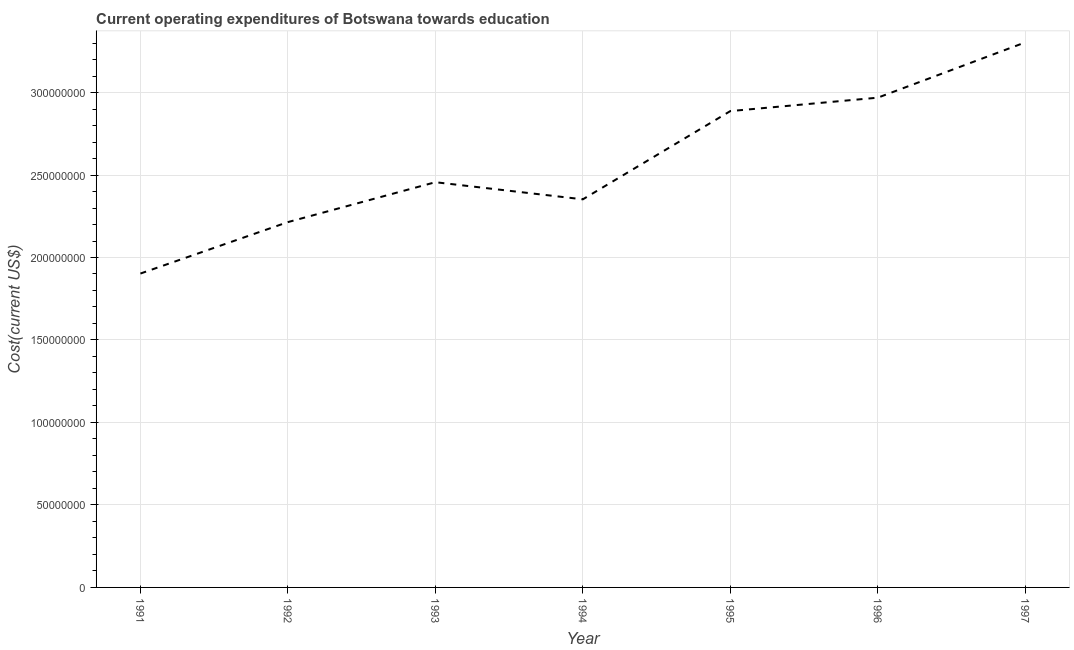What is the education expenditure in 1993?
Make the answer very short. 2.46e+08. Across all years, what is the maximum education expenditure?
Your response must be concise. 3.30e+08. Across all years, what is the minimum education expenditure?
Your response must be concise. 1.90e+08. In which year was the education expenditure minimum?
Provide a short and direct response. 1991. What is the sum of the education expenditure?
Offer a terse response. 1.81e+09. What is the difference between the education expenditure in 1996 and 1997?
Give a very brief answer. -3.35e+07. What is the average education expenditure per year?
Keep it short and to the point. 2.58e+08. What is the median education expenditure?
Provide a succinct answer. 2.46e+08. Do a majority of the years between 1996 and 1994 (inclusive) have education expenditure greater than 260000000 US$?
Your answer should be very brief. No. What is the ratio of the education expenditure in 1993 to that in 1997?
Your response must be concise. 0.74. What is the difference between the highest and the second highest education expenditure?
Keep it short and to the point. 3.35e+07. Is the sum of the education expenditure in 1991 and 1992 greater than the maximum education expenditure across all years?
Your response must be concise. Yes. What is the difference between the highest and the lowest education expenditure?
Make the answer very short. 1.40e+08. In how many years, is the education expenditure greater than the average education expenditure taken over all years?
Offer a terse response. 3. What is the difference between two consecutive major ticks on the Y-axis?
Offer a terse response. 5.00e+07. What is the title of the graph?
Give a very brief answer. Current operating expenditures of Botswana towards education. What is the label or title of the X-axis?
Offer a very short reply. Year. What is the label or title of the Y-axis?
Your response must be concise. Cost(current US$). What is the Cost(current US$) in 1991?
Provide a succinct answer. 1.90e+08. What is the Cost(current US$) in 1992?
Your response must be concise. 2.21e+08. What is the Cost(current US$) in 1993?
Make the answer very short. 2.46e+08. What is the Cost(current US$) in 1994?
Keep it short and to the point. 2.35e+08. What is the Cost(current US$) of 1995?
Your answer should be very brief. 2.89e+08. What is the Cost(current US$) in 1996?
Provide a succinct answer. 2.97e+08. What is the Cost(current US$) in 1997?
Your answer should be very brief. 3.30e+08. What is the difference between the Cost(current US$) in 1991 and 1992?
Make the answer very short. -3.12e+07. What is the difference between the Cost(current US$) in 1991 and 1993?
Ensure brevity in your answer.  -5.54e+07. What is the difference between the Cost(current US$) in 1991 and 1994?
Provide a succinct answer. -4.50e+07. What is the difference between the Cost(current US$) in 1991 and 1995?
Offer a very short reply. -9.85e+07. What is the difference between the Cost(current US$) in 1991 and 1996?
Keep it short and to the point. -1.07e+08. What is the difference between the Cost(current US$) in 1991 and 1997?
Your answer should be very brief. -1.40e+08. What is the difference between the Cost(current US$) in 1992 and 1993?
Your response must be concise. -2.42e+07. What is the difference between the Cost(current US$) in 1992 and 1994?
Your answer should be compact. -1.38e+07. What is the difference between the Cost(current US$) in 1992 and 1995?
Ensure brevity in your answer.  -6.73e+07. What is the difference between the Cost(current US$) in 1992 and 1996?
Make the answer very short. -7.54e+07. What is the difference between the Cost(current US$) in 1992 and 1997?
Make the answer very short. -1.09e+08. What is the difference between the Cost(current US$) in 1993 and 1994?
Your answer should be very brief. 1.04e+07. What is the difference between the Cost(current US$) in 1993 and 1995?
Your answer should be very brief. -4.31e+07. What is the difference between the Cost(current US$) in 1993 and 1996?
Your response must be concise. -5.12e+07. What is the difference between the Cost(current US$) in 1993 and 1997?
Provide a short and direct response. -8.48e+07. What is the difference between the Cost(current US$) in 1994 and 1995?
Ensure brevity in your answer.  -5.35e+07. What is the difference between the Cost(current US$) in 1994 and 1996?
Keep it short and to the point. -6.16e+07. What is the difference between the Cost(current US$) in 1994 and 1997?
Make the answer very short. -9.51e+07. What is the difference between the Cost(current US$) in 1995 and 1996?
Keep it short and to the point. -8.13e+06. What is the difference between the Cost(current US$) in 1995 and 1997?
Offer a terse response. -4.16e+07. What is the difference between the Cost(current US$) in 1996 and 1997?
Ensure brevity in your answer.  -3.35e+07. What is the ratio of the Cost(current US$) in 1991 to that in 1992?
Your answer should be very brief. 0.86. What is the ratio of the Cost(current US$) in 1991 to that in 1993?
Keep it short and to the point. 0.78. What is the ratio of the Cost(current US$) in 1991 to that in 1994?
Your answer should be very brief. 0.81. What is the ratio of the Cost(current US$) in 1991 to that in 1995?
Offer a very short reply. 0.66. What is the ratio of the Cost(current US$) in 1991 to that in 1996?
Your response must be concise. 0.64. What is the ratio of the Cost(current US$) in 1991 to that in 1997?
Your response must be concise. 0.58. What is the ratio of the Cost(current US$) in 1992 to that in 1993?
Your answer should be very brief. 0.9. What is the ratio of the Cost(current US$) in 1992 to that in 1994?
Ensure brevity in your answer.  0.94. What is the ratio of the Cost(current US$) in 1992 to that in 1995?
Make the answer very short. 0.77. What is the ratio of the Cost(current US$) in 1992 to that in 1996?
Your answer should be compact. 0.75. What is the ratio of the Cost(current US$) in 1992 to that in 1997?
Offer a very short reply. 0.67. What is the ratio of the Cost(current US$) in 1993 to that in 1994?
Make the answer very short. 1.04. What is the ratio of the Cost(current US$) in 1993 to that in 1995?
Your response must be concise. 0.85. What is the ratio of the Cost(current US$) in 1993 to that in 1996?
Your response must be concise. 0.83. What is the ratio of the Cost(current US$) in 1993 to that in 1997?
Make the answer very short. 0.74. What is the ratio of the Cost(current US$) in 1994 to that in 1995?
Provide a succinct answer. 0.81. What is the ratio of the Cost(current US$) in 1994 to that in 1996?
Your answer should be very brief. 0.79. What is the ratio of the Cost(current US$) in 1994 to that in 1997?
Offer a very short reply. 0.71. What is the ratio of the Cost(current US$) in 1995 to that in 1996?
Your answer should be very brief. 0.97. What is the ratio of the Cost(current US$) in 1995 to that in 1997?
Offer a terse response. 0.87. What is the ratio of the Cost(current US$) in 1996 to that in 1997?
Ensure brevity in your answer.  0.9. 